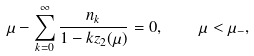<formula> <loc_0><loc_0><loc_500><loc_500>\mu - \sum _ { k = 0 } ^ { \infty } \frac { n _ { k } } { 1 - k z _ { 2 } ( \mu ) } = 0 , \quad \mu < \mu _ { - } ,</formula> 